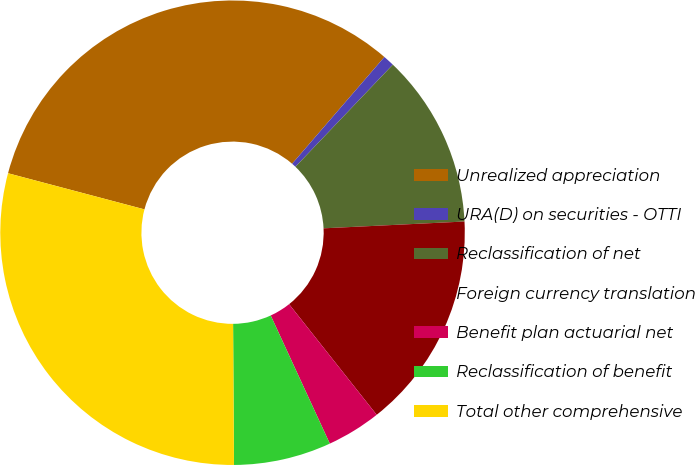<chart> <loc_0><loc_0><loc_500><loc_500><pie_chart><fcel>Unrealized appreciation<fcel>URA(D) on securities - OTTI<fcel>Reclassification of net<fcel>Foreign currency translation<fcel>Benefit plan actuarial net<fcel>Reclassification of benefit<fcel>Total other comprehensive<nl><fcel>32.22%<fcel>0.78%<fcel>12.11%<fcel>15.11%<fcel>3.78%<fcel>6.78%<fcel>29.22%<nl></chart> 